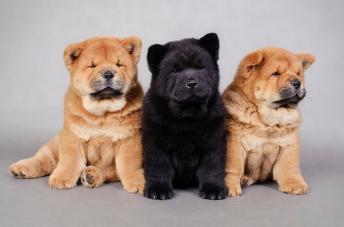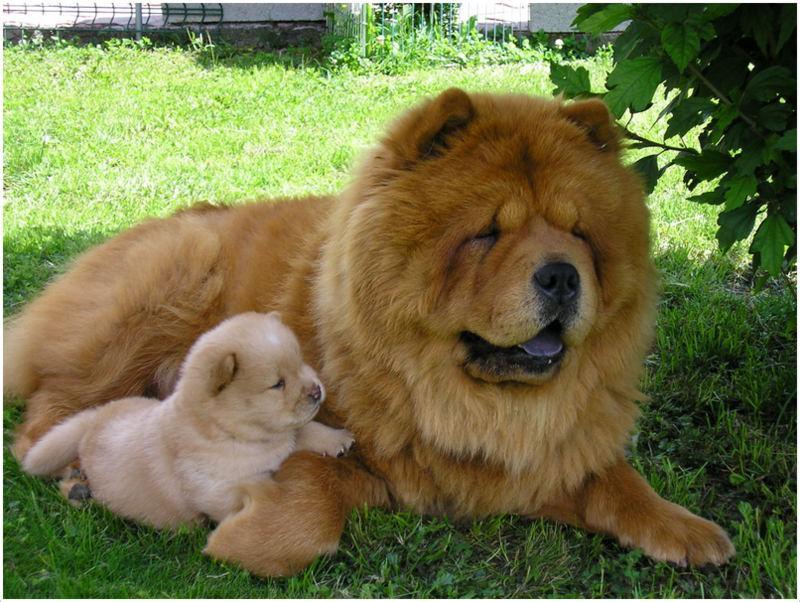The first image is the image on the left, the second image is the image on the right. For the images displayed, is the sentence "Right and left images contain the same number of dogs." factually correct? Answer yes or no. No. The first image is the image on the left, the second image is the image on the right. For the images displayed, is the sentence "There are two dogs in total." factually correct? Answer yes or no. No. 